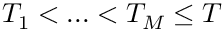Convert formula to latex. <formula><loc_0><loc_0><loc_500><loc_500>T _ { 1 } < \dots < T _ { M } \leq T</formula> 